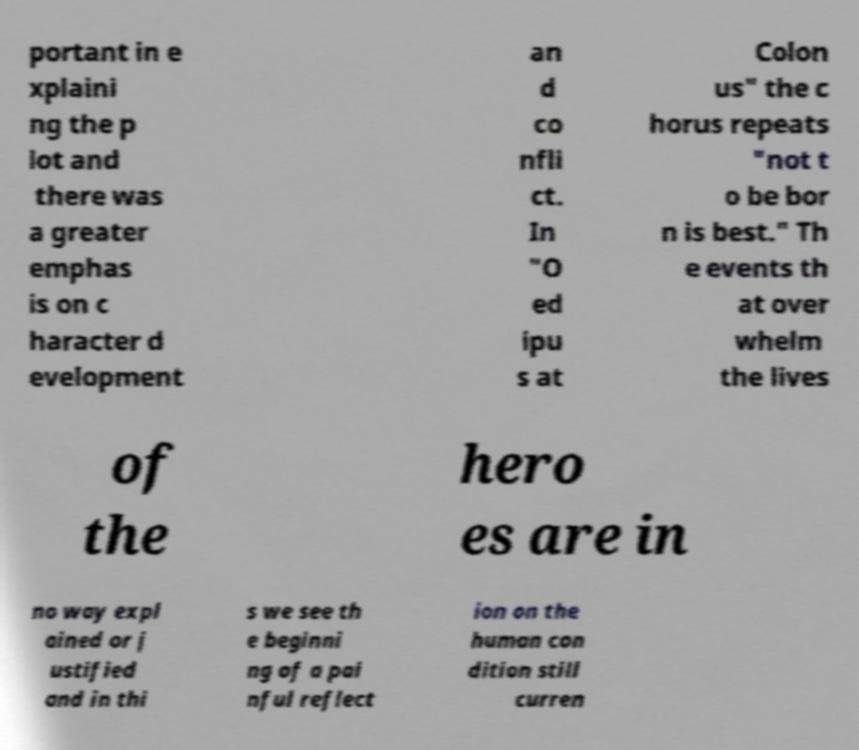Please identify and transcribe the text found in this image. portant in e xplaini ng the p lot and there was a greater emphas is on c haracter d evelopment an d co nfli ct. In "O ed ipu s at Colon us" the c horus repeats "not t o be bor n is best." Th e events th at over whelm the lives of the hero es are in no way expl ained or j ustified and in thi s we see th e beginni ng of a pai nful reflect ion on the human con dition still curren 